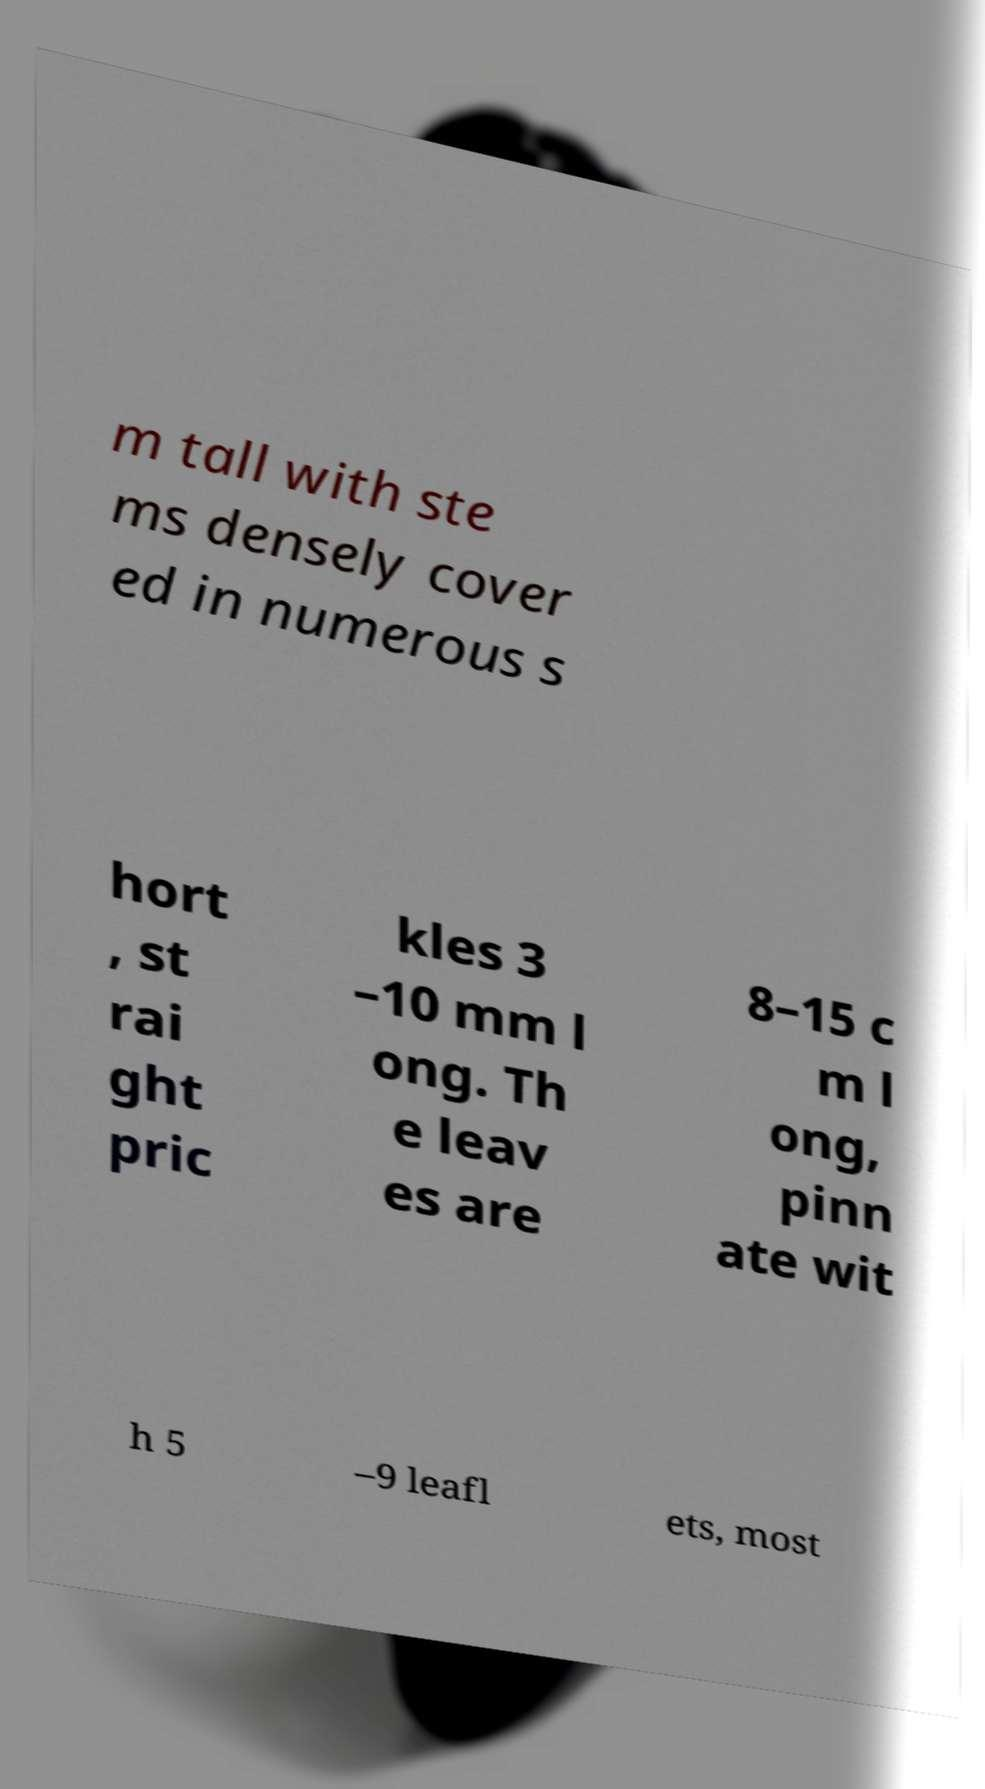What messages or text are displayed in this image? I need them in a readable, typed format. m tall with ste ms densely cover ed in numerous s hort , st rai ght pric kles 3 –10 mm l ong. Th e leav es are 8–15 c m l ong, pinn ate wit h 5 –9 leafl ets, most 